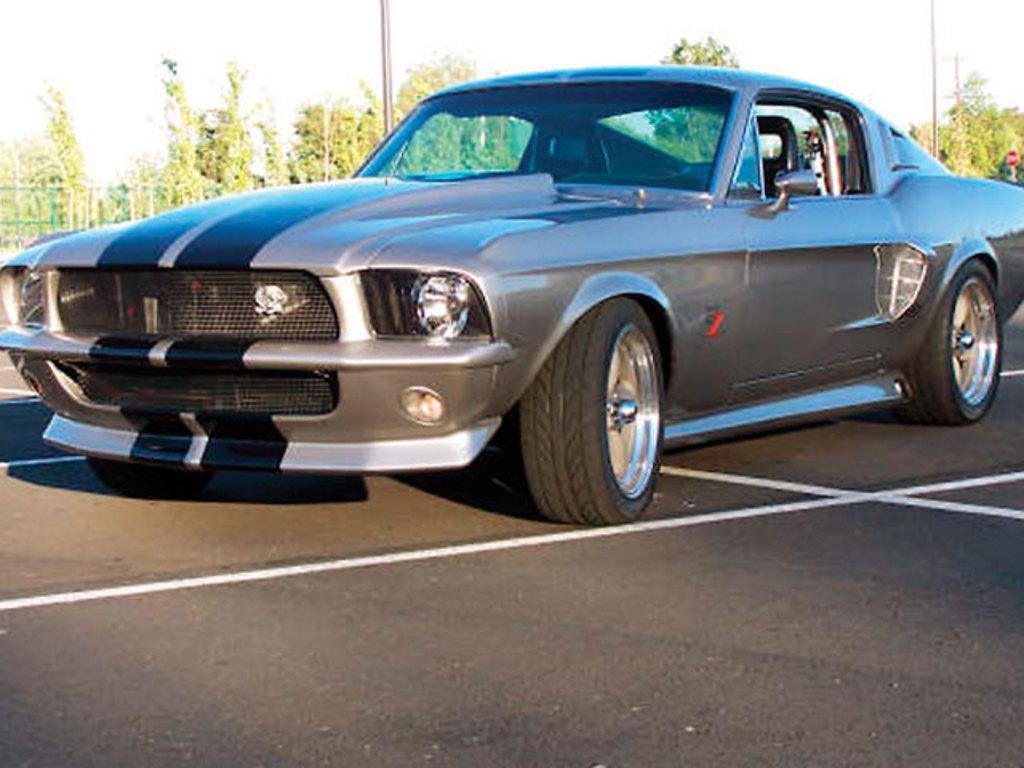Can you describe this image briefly? In this picture we can see a car on the road. In the background we can see poles, trees, fence and the sky. 